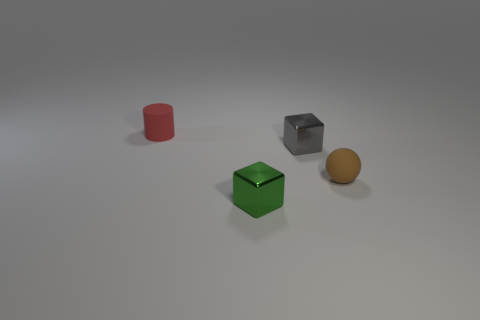Are there any other things that are the same shape as the tiny brown object?
Make the answer very short. No. What color is the small matte object that is in front of the red rubber cylinder?
Your answer should be very brief. Brown. There is a tiny cylinder on the left side of the small brown rubber object; what is it made of?
Keep it short and to the point. Rubber. There is a matte object in front of the tiny gray block; how many matte things are on the left side of it?
Ensure brevity in your answer.  1. Are there any tiny green things of the same shape as the gray metal object?
Offer a terse response. Yes. Is the size of the object that is to the left of the green cube the same as the metallic thing that is in front of the small gray cube?
Ensure brevity in your answer.  Yes. There is a tiny matte thing that is left of the small rubber thing that is right of the tiny cylinder; what is its shape?
Your answer should be compact. Cylinder. What number of cyan metallic balls have the same size as the gray cube?
Keep it short and to the point. 0. Is there a cube?
Ensure brevity in your answer.  Yes. Is there anything else of the same color as the tiny cylinder?
Provide a succinct answer. No. 